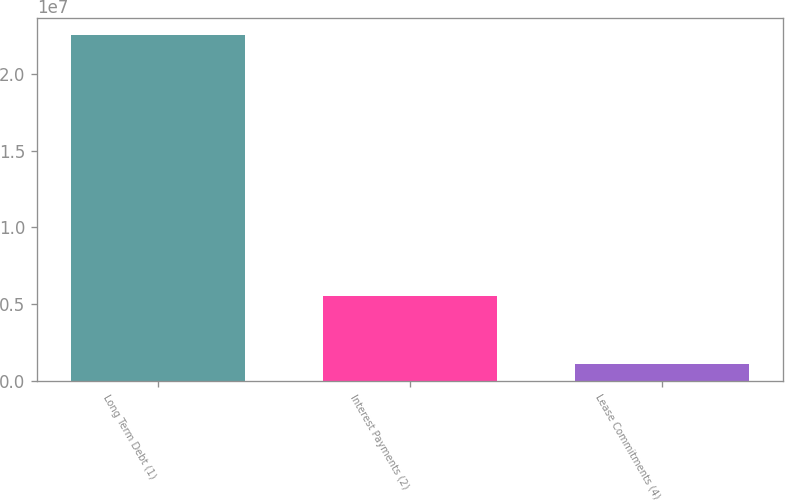<chart> <loc_0><loc_0><loc_500><loc_500><bar_chart><fcel>Long Term Debt (1)<fcel>Interest Payments (2)<fcel>Lease Commitments (4)<nl><fcel>2.25023e+07<fcel>5.52962e+06<fcel>1.12818e+06<nl></chart> 